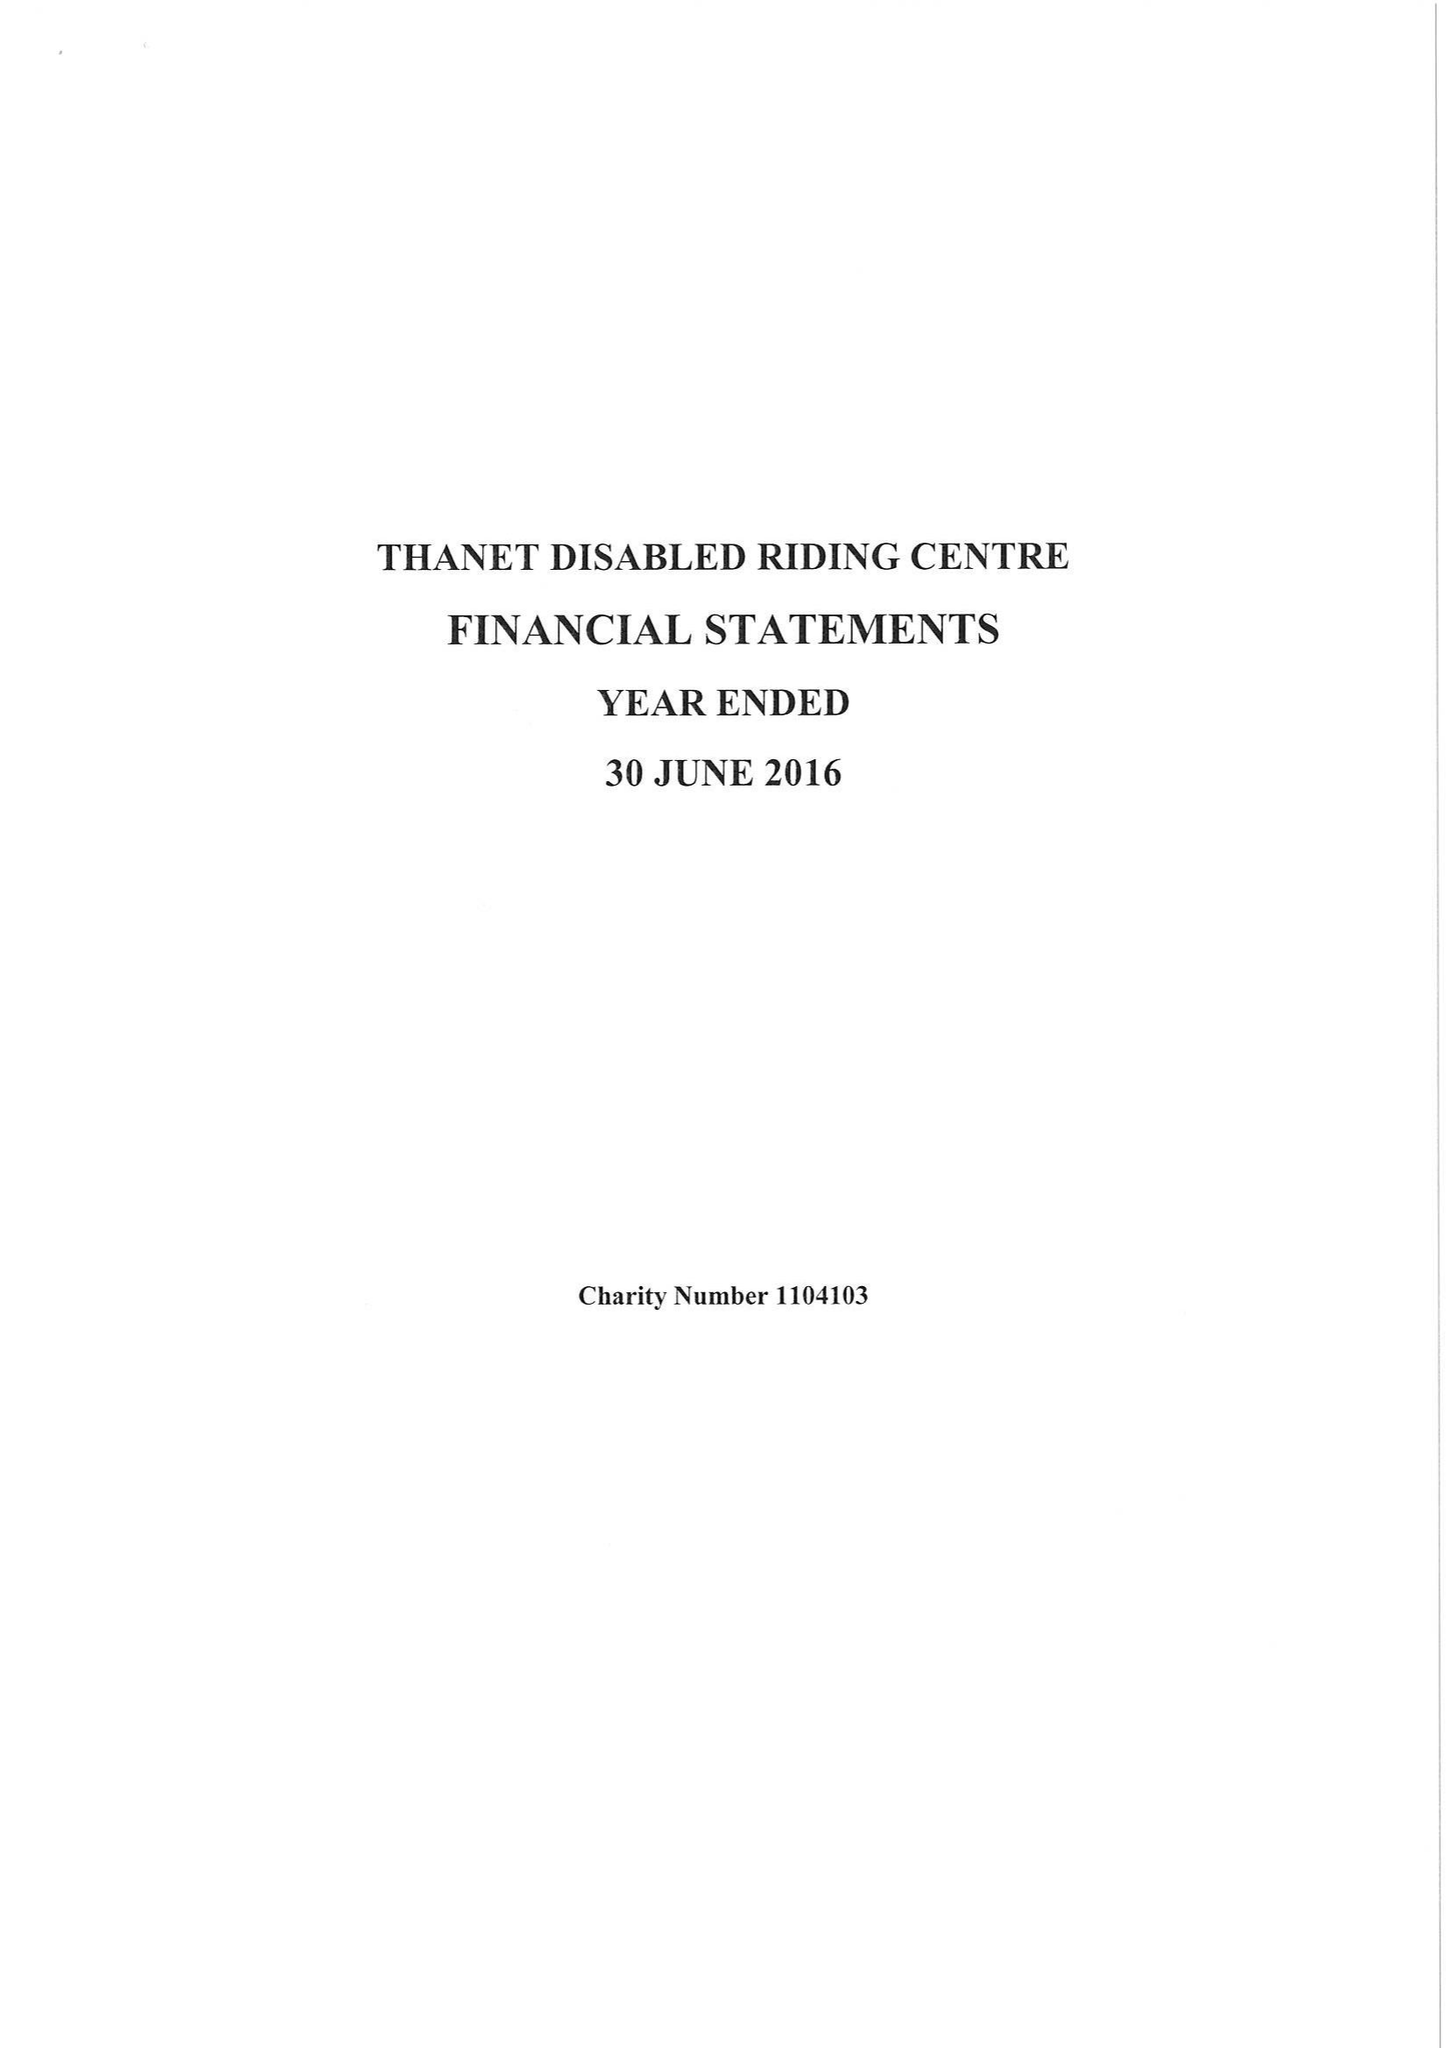What is the value for the address__postcode?
Answer the question using a single word or phrase. CT10 1HY 